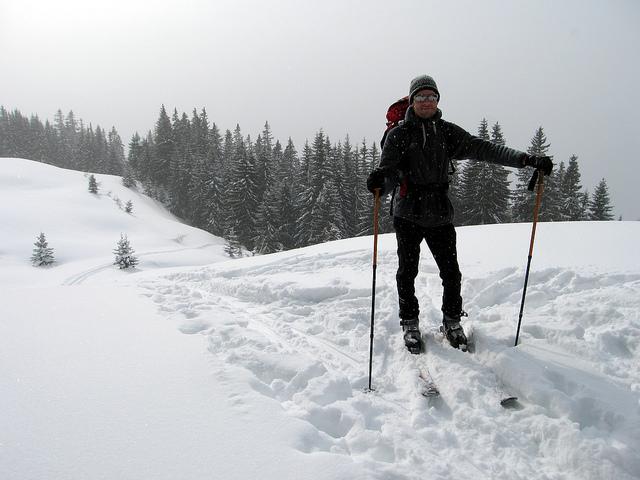What tracks are in the snow?
Quick response, please. Ski. Is it cold out?
Keep it brief. Yes. Has it snowed recently?
Give a very brief answer. Yes. What time of year is this photo taken?
Write a very short answer. Winter. Is the man on the right holding ski poles?
Write a very short answer. Yes. Why is the snow disturbed?
Concise answer only. Skiing. Is the man tired?
Give a very brief answer. No. 